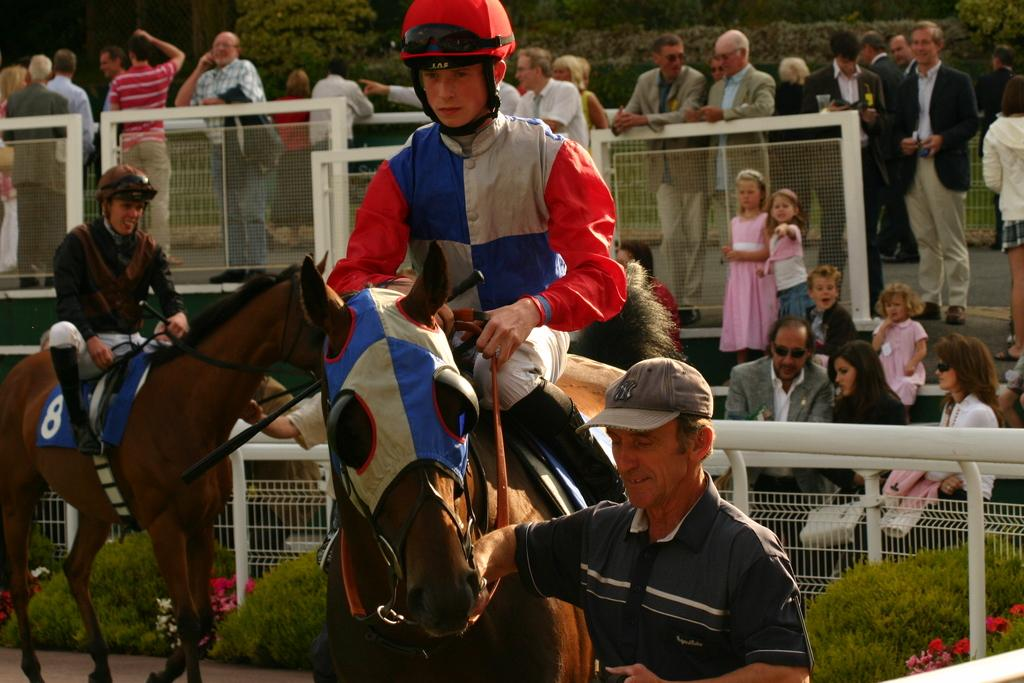What is the person in the image doing? There is a person sitting on a horse in the image. Can you describe the position of the other person in the image? There is a person standing in the image. Are there any other people visible in the image? Yes, there is a group of people standing in the background. What type of cheese is being served to the owl in the image? There is no owl or cheese present in the image. 